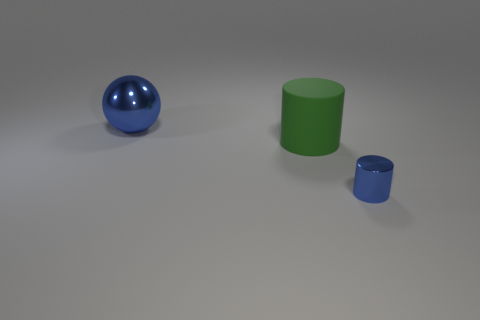What number of yellow metal cylinders are there?
Keep it short and to the point. 0. There is a tiny blue object; does it have the same shape as the big thing that is in front of the big ball?
Your answer should be compact. Yes. What is the size of the shiny cylinder that is the same color as the big metal ball?
Keep it short and to the point. Small. How many things are tiny blue metallic cylinders or gray rubber objects?
Your answer should be compact. 1. There is a blue shiny object that is to the left of the object to the right of the large cylinder; what is its shape?
Provide a short and direct response. Sphere. Do the blue metal object that is in front of the big ball and the large blue thing have the same shape?
Offer a terse response. No. The object that is the same material as the big sphere is what size?
Make the answer very short. Small. How many objects are either blue shiny things that are behind the tiny blue object or blue metal objects right of the ball?
Make the answer very short. 2. Are there an equal number of small blue metal cylinders behind the blue ball and shiny cylinders on the left side of the green object?
Keep it short and to the point. Yes. There is a big thing in front of the big blue metal ball; what is its color?
Give a very brief answer. Green. 